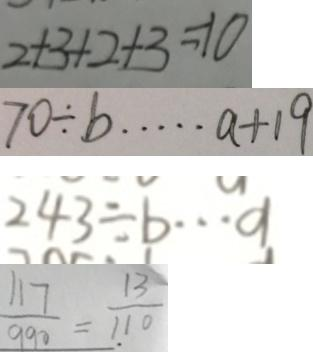Convert formula to latex. <formula><loc_0><loc_0><loc_500><loc_500>2 + 3 + 2 + 3 = 1 0 
 7 0 \div b \cdots a + 1 9 
 2 4 3 \div b \cdots a 
 \frac { 1 1 7 } { 9 9 0 } = \frac { 1 3 } { 1 1 0 }</formula> 